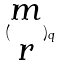Convert formula to latex. <formula><loc_0><loc_0><loc_500><loc_500>( \begin{matrix} m \\ r \end{matrix} ) _ { q }</formula> 